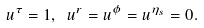<formula> <loc_0><loc_0><loc_500><loc_500>u ^ { \tau } = 1 , \ u ^ { r } = u ^ { \phi } = u ^ { \eta _ { s } } = 0 .</formula> 